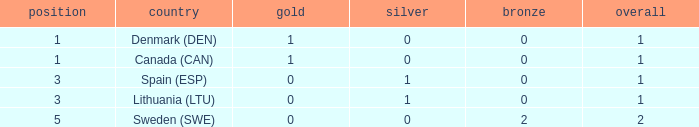What is the total when there were less than 0 bronze? 0.0. 